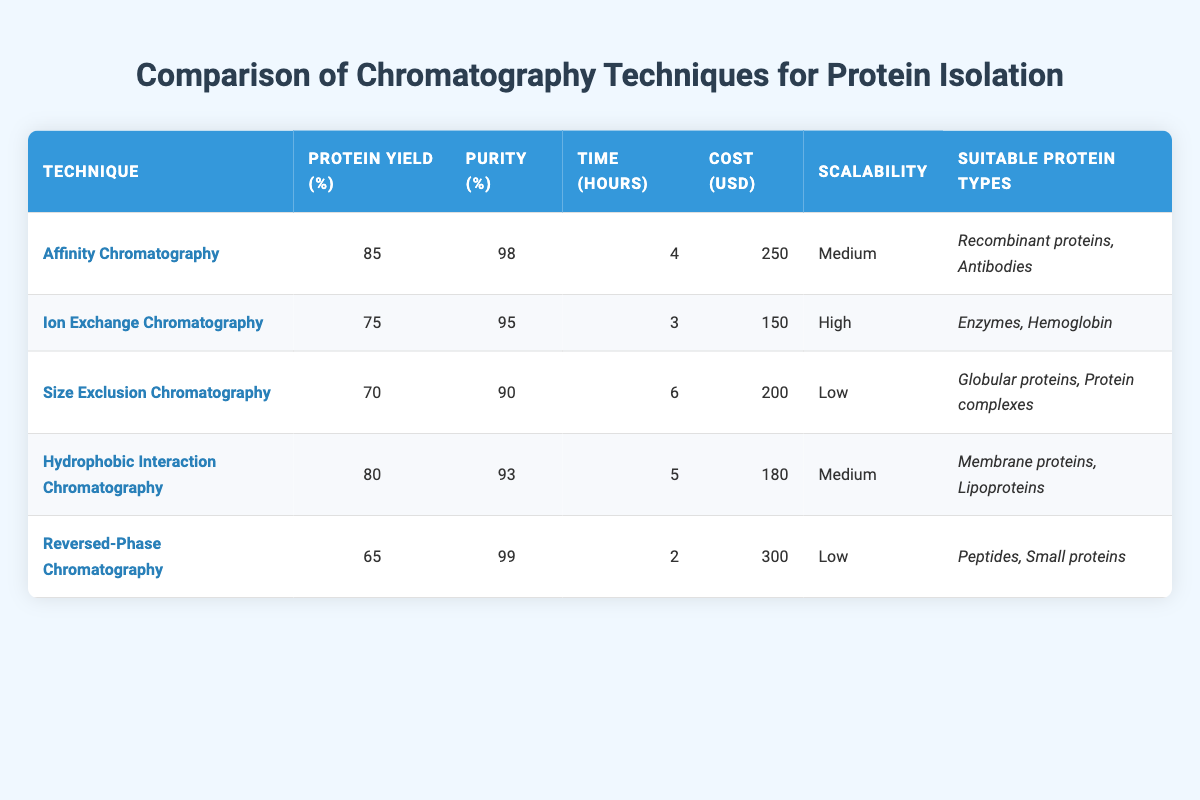What is the protein yield of Affinity Chromatography? The table shows the protein yield for Affinity Chromatography as 85%.
Answer: 85% Which chromatography technique has the highest purity percentage? The table lists the purity percentages, and Reversed-Phase Chromatography has the highest at 99%.
Answer: 99% How much does it cost per run for Ion Exchange Chromatography? The table states that the cost per run for Ion Exchange Chromatography is 150 USD.
Answer: 150 What is the average protein yield of the chromatography techniques listed? The protein yields are 85, 75, 70, 80, and 65. Summing them gives 85 + 75 + 70 + 80 + 65 = 375. Dividing by 5 yields an average of 375 / 5 = 75.
Answer: 75 Is Size Exclusion Chromatography suitable for recombinant proteins? The suitable protein types listed for Size Exclusion Chromatography are globular proteins and protein complexes, not recombinant proteins. Therefore, the answer is no.
Answer: No Which chromatography technique requires the least time for a run? In the table, Reversed-Phase Chromatography has the least time requirement at 2 hours compared to other techniques.
Answer: 2 hours Does Hydrophobic Interaction Chromatography have a medium scalability? The table indicates that Hydrophobic Interaction Chromatography's scalability is categorized as medium. Therefore, the answer is yes.
Answer: Yes What is the difference in cost per run between the most expensive and least expensive techniques? The most expensive is Reversed-Phase Chromatography at 300 USD and the least is Ion Exchange Chromatography at 150 USD. The difference is 300 - 150 = 150.
Answer: 150 List the suitable protein types for Affinity Chromatography. The table shows that Affinity Chromatography is suitable for recombinant proteins and antibodies, which can be directly found in the corresponding column of the table.
Answer: Recombinant proteins, Antibodies Which technique offers the lowest protein yield, and what is that yield? The table indicates that Reversed-Phase Chromatography has the lowest protein yield at 65%.
Answer: Reversed-Phase Chromatography, 65% 